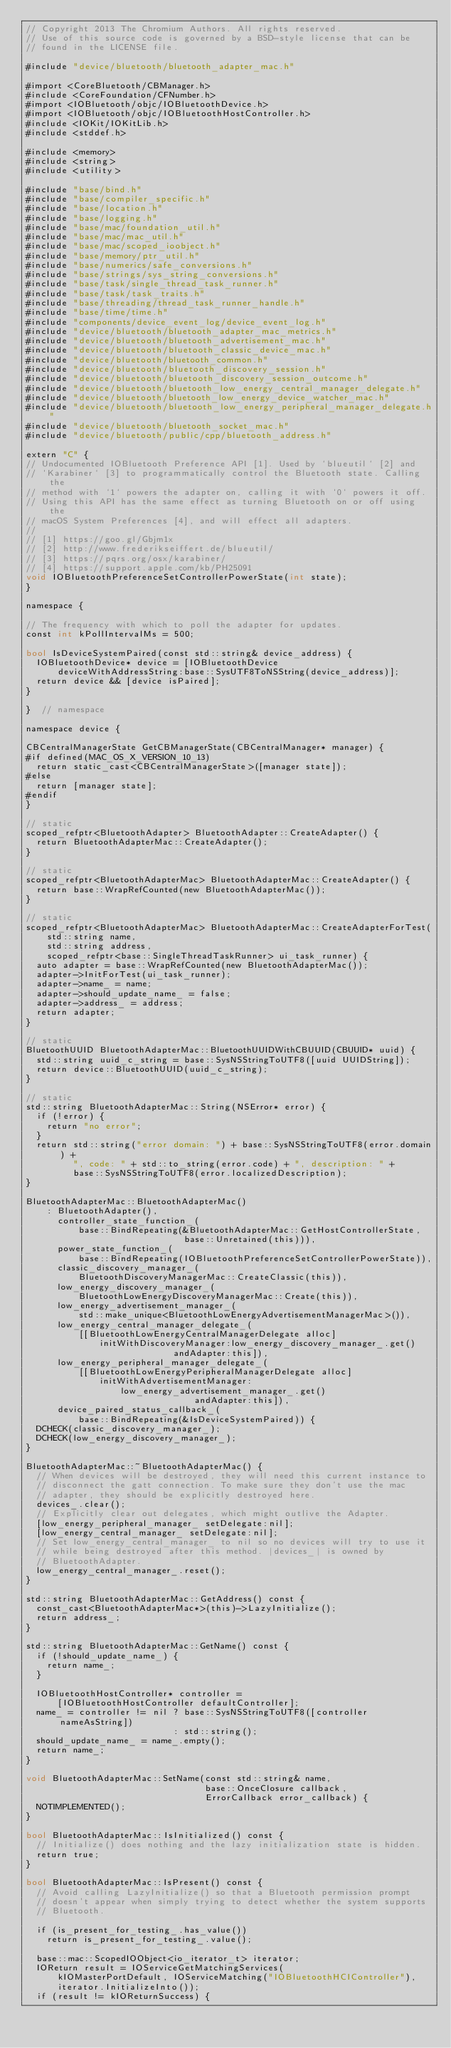<code> <loc_0><loc_0><loc_500><loc_500><_ObjectiveC_>// Copyright 2013 The Chromium Authors. All rights reserved.
// Use of this source code is governed by a BSD-style license that can be
// found in the LICENSE file.

#include "device/bluetooth/bluetooth_adapter_mac.h"

#import <CoreBluetooth/CBManager.h>
#include <CoreFoundation/CFNumber.h>
#import <IOBluetooth/objc/IOBluetoothDevice.h>
#import <IOBluetooth/objc/IOBluetoothHostController.h>
#include <IOKit/IOKitLib.h>
#include <stddef.h>

#include <memory>
#include <string>
#include <utility>

#include "base/bind.h"
#include "base/compiler_specific.h"
#include "base/location.h"
#include "base/logging.h"
#include "base/mac/foundation_util.h"
#include "base/mac/mac_util.h"
#include "base/mac/scoped_ioobject.h"
#include "base/memory/ptr_util.h"
#include "base/numerics/safe_conversions.h"
#include "base/strings/sys_string_conversions.h"
#include "base/task/single_thread_task_runner.h"
#include "base/task/task_traits.h"
#include "base/threading/thread_task_runner_handle.h"
#include "base/time/time.h"
#include "components/device_event_log/device_event_log.h"
#include "device/bluetooth/bluetooth_adapter_mac_metrics.h"
#include "device/bluetooth/bluetooth_advertisement_mac.h"
#include "device/bluetooth/bluetooth_classic_device_mac.h"
#include "device/bluetooth/bluetooth_common.h"
#include "device/bluetooth/bluetooth_discovery_session.h"
#include "device/bluetooth/bluetooth_discovery_session_outcome.h"
#include "device/bluetooth/bluetooth_low_energy_central_manager_delegate.h"
#include "device/bluetooth/bluetooth_low_energy_device_watcher_mac.h"
#include "device/bluetooth/bluetooth_low_energy_peripheral_manager_delegate.h"
#include "device/bluetooth/bluetooth_socket_mac.h"
#include "device/bluetooth/public/cpp/bluetooth_address.h"

extern "C" {
// Undocumented IOBluetooth Preference API [1]. Used by `blueutil` [2] and
// `Karabiner` [3] to programmatically control the Bluetooth state. Calling the
// method with `1` powers the adapter on, calling it with `0` powers it off.
// Using this API has the same effect as turning Bluetooth on or off using the
// macOS System Preferences [4], and will effect all adapters.
//
// [1] https://goo.gl/Gbjm1x
// [2] http://www.frederikseiffert.de/blueutil/
// [3] https://pqrs.org/osx/karabiner/
// [4] https://support.apple.com/kb/PH25091
void IOBluetoothPreferenceSetControllerPowerState(int state);
}

namespace {

// The frequency with which to poll the adapter for updates.
const int kPollIntervalMs = 500;

bool IsDeviceSystemPaired(const std::string& device_address) {
  IOBluetoothDevice* device = [IOBluetoothDevice
      deviceWithAddressString:base::SysUTF8ToNSString(device_address)];
  return device && [device isPaired];
}

}  // namespace

namespace device {

CBCentralManagerState GetCBManagerState(CBCentralManager* manager) {
#if defined(MAC_OS_X_VERSION_10_13)
  return static_cast<CBCentralManagerState>([manager state]);
#else
  return [manager state];
#endif
}

// static
scoped_refptr<BluetoothAdapter> BluetoothAdapter::CreateAdapter() {
  return BluetoothAdapterMac::CreateAdapter();
}

// static
scoped_refptr<BluetoothAdapterMac> BluetoothAdapterMac::CreateAdapter() {
  return base::WrapRefCounted(new BluetoothAdapterMac());
}

// static
scoped_refptr<BluetoothAdapterMac> BluetoothAdapterMac::CreateAdapterForTest(
    std::string name,
    std::string address,
    scoped_refptr<base::SingleThreadTaskRunner> ui_task_runner) {
  auto adapter = base::WrapRefCounted(new BluetoothAdapterMac());
  adapter->InitForTest(ui_task_runner);
  adapter->name_ = name;
  adapter->should_update_name_ = false;
  adapter->address_ = address;
  return adapter;
}

// static
BluetoothUUID BluetoothAdapterMac::BluetoothUUIDWithCBUUID(CBUUID* uuid) {
  std::string uuid_c_string = base::SysNSStringToUTF8([uuid UUIDString]);
  return device::BluetoothUUID(uuid_c_string);
}

// static
std::string BluetoothAdapterMac::String(NSError* error) {
  if (!error) {
    return "no error";
  }
  return std::string("error domain: ") + base::SysNSStringToUTF8(error.domain) +
         ", code: " + std::to_string(error.code) + ", description: " +
         base::SysNSStringToUTF8(error.localizedDescription);
}

BluetoothAdapterMac::BluetoothAdapterMac()
    : BluetoothAdapter(),
      controller_state_function_(
          base::BindRepeating(&BluetoothAdapterMac::GetHostControllerState,
                              base::Unretained(this))),
      power_state_function_(
          base::BindRepeating(IOBluetoothPreferenceSetControllerPowerState)),
      classic_discovery_manager_(
          BluetoothDiscoveryManagerMac::CreateClassic(this)),
      low_energy_discovery_manager_(
          BluetoothLowEnergyDiscoveryManagerMac::Create(this)),
      low_energy_advertisement_manager_(
          std::make_unique<BluetoothLowEnergyAdvertisementManagerMac>()),
      low_energy_central_manager_delegate_(
          [[BluetoothLowEnergyCentralManagerDelegate alloc]
              initWithDiscoveryManager:low_energy_discovery_manager_.get()
                            andAdapter:this]),
      low_energy_peripheral_manager_delegate_(
          [[BluetoothLowEnergyPeripheralManagerDelegate alloc]
              initWithAdvertisementManager:
                  low_energy_advertisement_manager_.get()
                                andAdapter:this]),
      device_paired_status_callback_(
          base::BindRepeating(&IsDeviceSystemPaired)) {
  DCHECK(classic_discovery_manager_);
  DCHECK(low_energy_discovery_manager_);
}

BluetoothAdapterMac::~BluetoothAdapterMac() {
  // When devices will be destroyed, they will need this current instance to
  // disconnect the gatt connection. To make sure they don't use the mac
  // adapter, they should be explicitly destroyed here.
  devices_.clear();
  // Explicitly clear out delegates, which might outlive the Adapter.
  [low_energy_peripheral_manager_ setDelegate:nil];
  [low_energy_central_manager_ setDelegate:nil];
  // Set low_energy_central_manager_ to nil so no devices will try to use it
  // while being destroyed after this method. |devices_| is owned by
  // BluetoothAdapter.
  low_energy_central_manager_.reset();
}

std::string BluetoothAdapterMac::GetAddress() const {
  const_cast<BluetoothAdapterMac*>(this)->LazyInitialize();
  return address_;
}

std::string BluetoothAdapterMac::GetName() const {
  if (!should_update_name_) {
    return name_;
  }

  IOBluetoothHostController* controller =
      [IOBluetoothHostController defaultController];
  name_ = controller != nil ? base::SysNSStringToUTF8([controller nameAsString])
                            : std::string();
  should_update_name_ = name_.empty();
  return name_;
}

void BluetoothAdapterMac::SetName(const std::string& name,
                                  base::OnceClosure callback,
                                  ErrorCallback error_callback) {
  NOTIMPLEMENTED();
}

bool BluetoothAdapterMac::IsInitialized() const {
  // Initialize() does nothing and the lazy initialization state is hidden.
  return true;
}

bool BluetoothAdapterMac::IsPresent() const {
  // Avoid calling LazyInitialize() so that a Bluetooth permission prompt
  // doesn't appear when simply trying to detect whether the system supports
  // Bluetooth.

  if (is_present_for_testing_.has_value())
    return is_present_for_testing_.value();

  base::mac::ScopedIOObject<io_iterator_t> iterator;
  IOReturn result = IOServiceGetMatchingServices(
      kIOMasterPortDefault, IOServiceMatching("IOBluetoothHCIController"),
      iterator.InitializeInto());
  if (result != kIOReturnSuccess) {</code> 